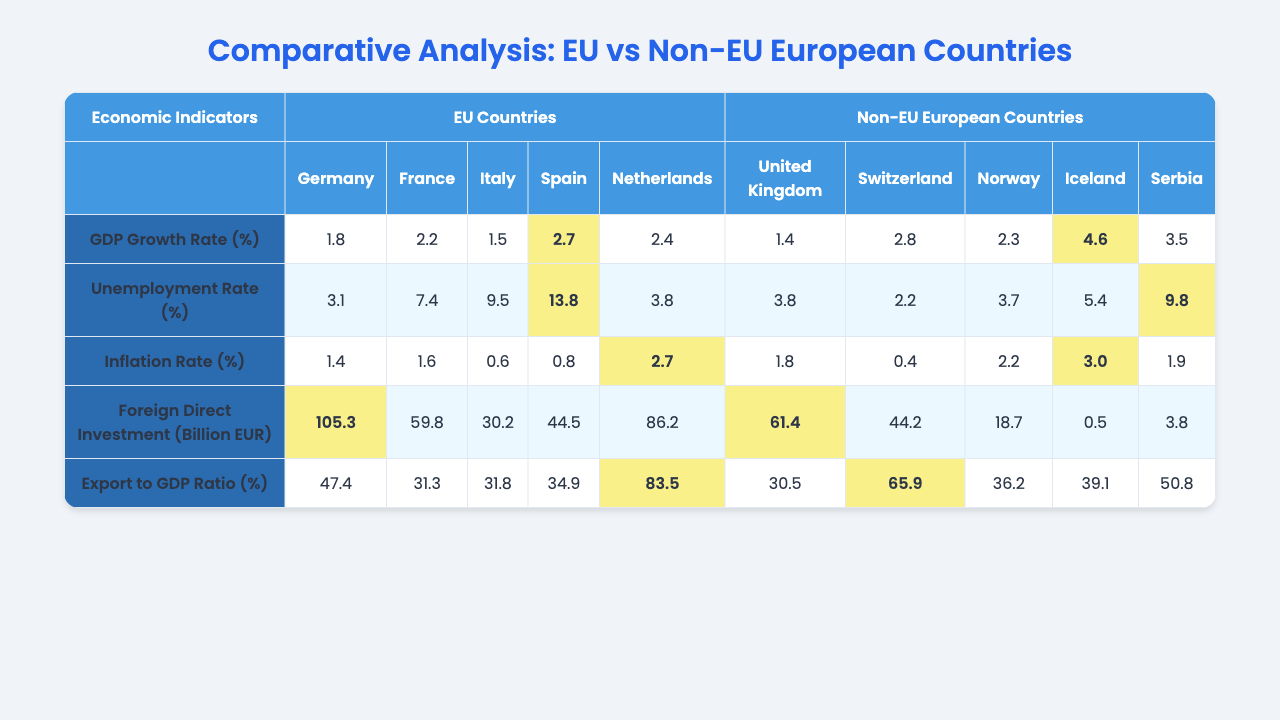What is the GDP growth rate of Switzerland? The table shows the GDP growth rate under the Non-EU European Countries section, and for Switzerland, it is listed as 2.8%.
Answer: 2.8% Which country has the lowest unemployment rate among EU countries? Looking at the Unemployment Rate section for EU Countries, Germany has the lowest rate at 3.1%.
Answer: Germany What is the inflation rate for Iceland? The inflation rate can be found in the Inflation Rate section under Non-EU European Countries, where Iceland is represented with a rate of 3.0%.
Answer: 3.0% Which country has the highest foreign direct investment in EU countries? Under Foreign Direct Investment for EU Countries, Germany is reported to have the highest value of 105.3 billion EUR.
Answer: Germany What is the average unemployment rate of Non-EU European countries? To find the average, we sum the unemployment rates of the Non-EU countries: (3.8 + 2.2 + 3.7 + 5.4 + 9.8) = 25.9. Dividing by 5 gives us an average of 25.9 / 5 = 5.18%.
Answer: 5.18% Which EU country has the highest Export to GDP Ratio? By examining the Export to GDP Ratio, we see that the Netherlands has the highest ratio at 83.5%.
Answer: Netherlands Is the GDP growth rate of Serbia higher than that of Italy? Serbia's GDP growth rate is 3.5%, while Italy's is 1.5%. Comparing these values shows that Serbia's rate is indeed higher than Italy's.
Answer: Yes Calculate the difference in Inflation Rate between France and Switzerland. France has an inflation rate of 1.6%, and Switzerland's is 0.4%. The difference calculated as 1.6 - 0.4 = 1.2%.
Answer: 1.2% How does Italy's GDP growth rate compare to that of Norway? Italy has a GDP growth rate of 1.5%, while Norway's is 2.3%. Since 2.3% is greater than 1.5%, we can conclude that Norway's growth rate is higher.
Answer: Norway is higher Which country has the highest foreign direct investment to GDP ratio, EU or Non-EU? The highest foreign direct investment in the EU is 105.3 billion EUR (Germany), and in Non-EU it is 61.4 billion EUR (UK). Therefore, the EU has a higher total.
Answer: EU countries have higher FDI 